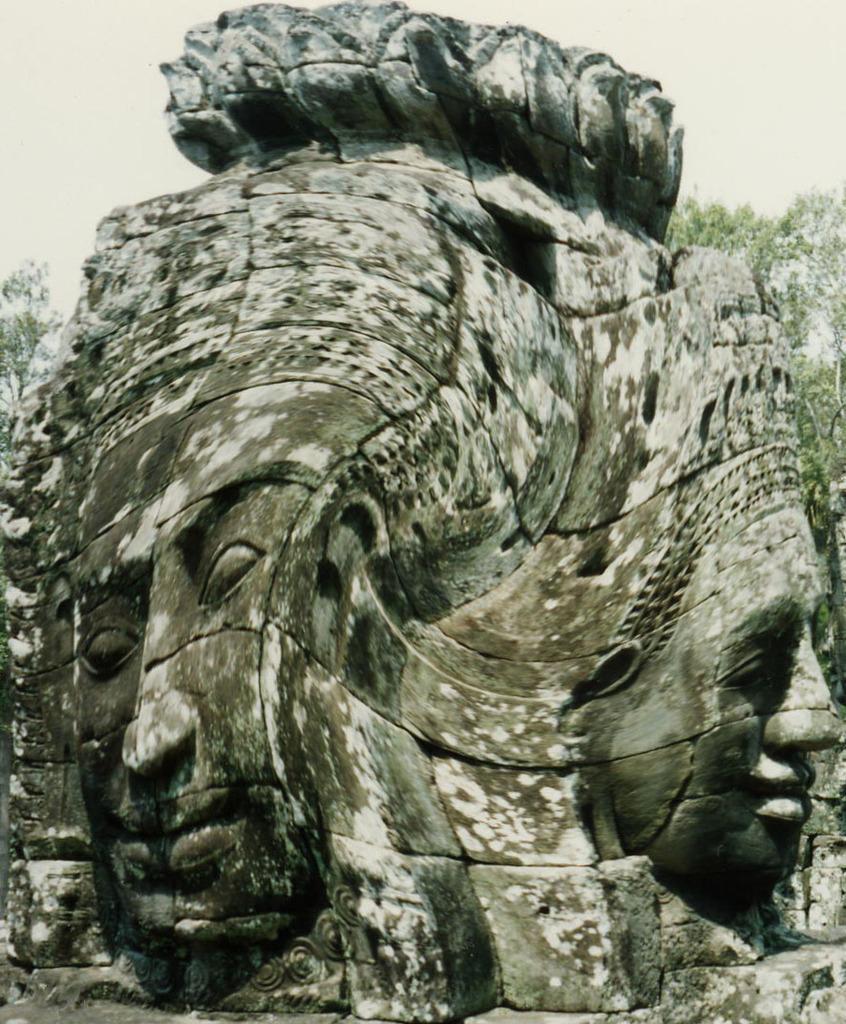In one or two sentences, can you explain what this image depicts? In the image there are carvings of humans on huge rock and behind there are trees and above its sky. 